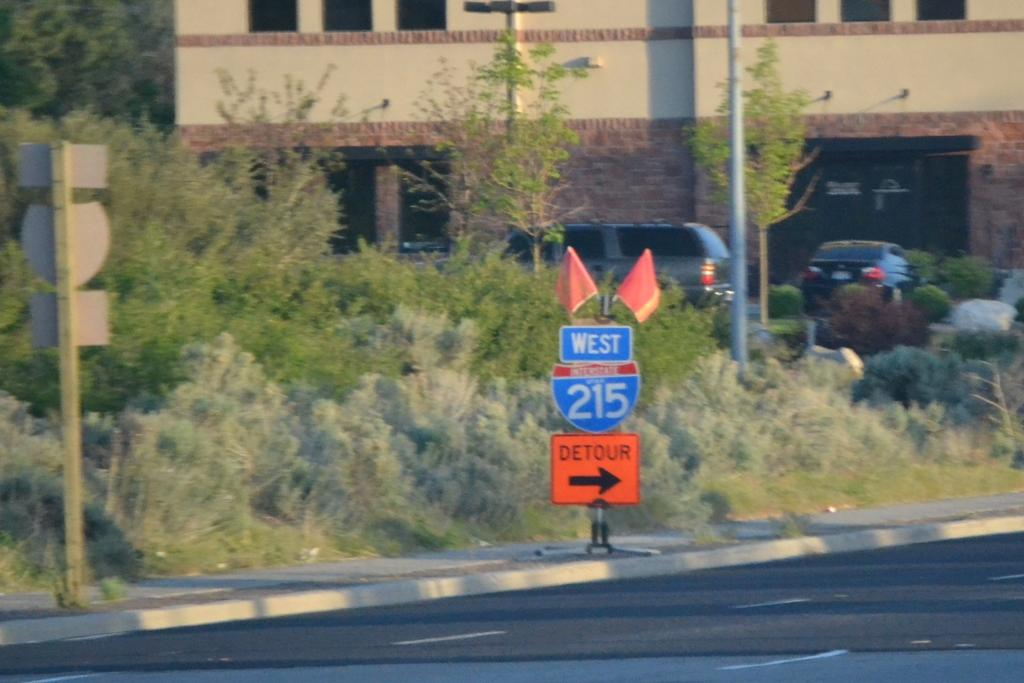<image>
Relay a brief, clear account of the picture shown. a 215 sign that is in blue above a detour one 